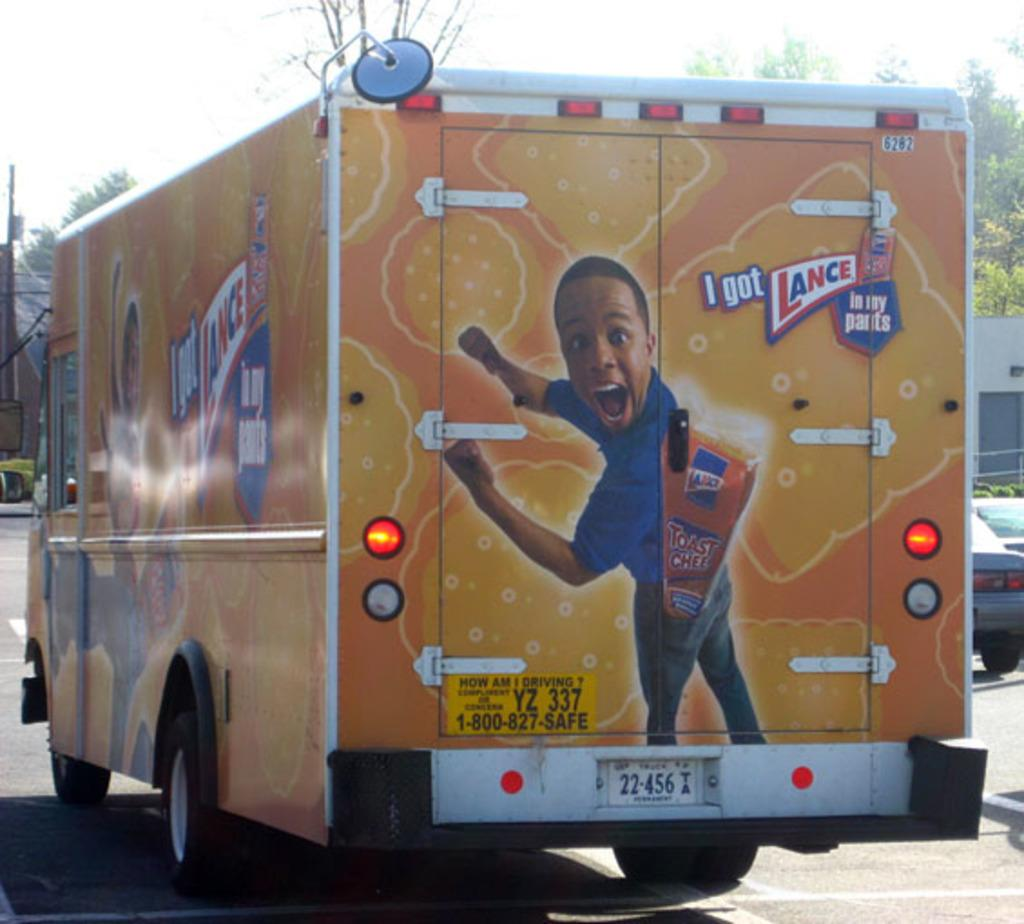What can be seen on the road in the image? There are vehicles on the road in the image. What type of natural elements are visible in the background of the image? There are trees visible in the background of the image. What else can be seen in the background of the image besides trees? There are objects in the background of the image. What is visible above the objects and trees in the background of the image? The sky is visible in the background of the image. What type of instrument is being played by the bird in the image? There are no birds or instruments present in the image. What punishment is being given to the person in the image? There is no person or punishment depicted in the image. 